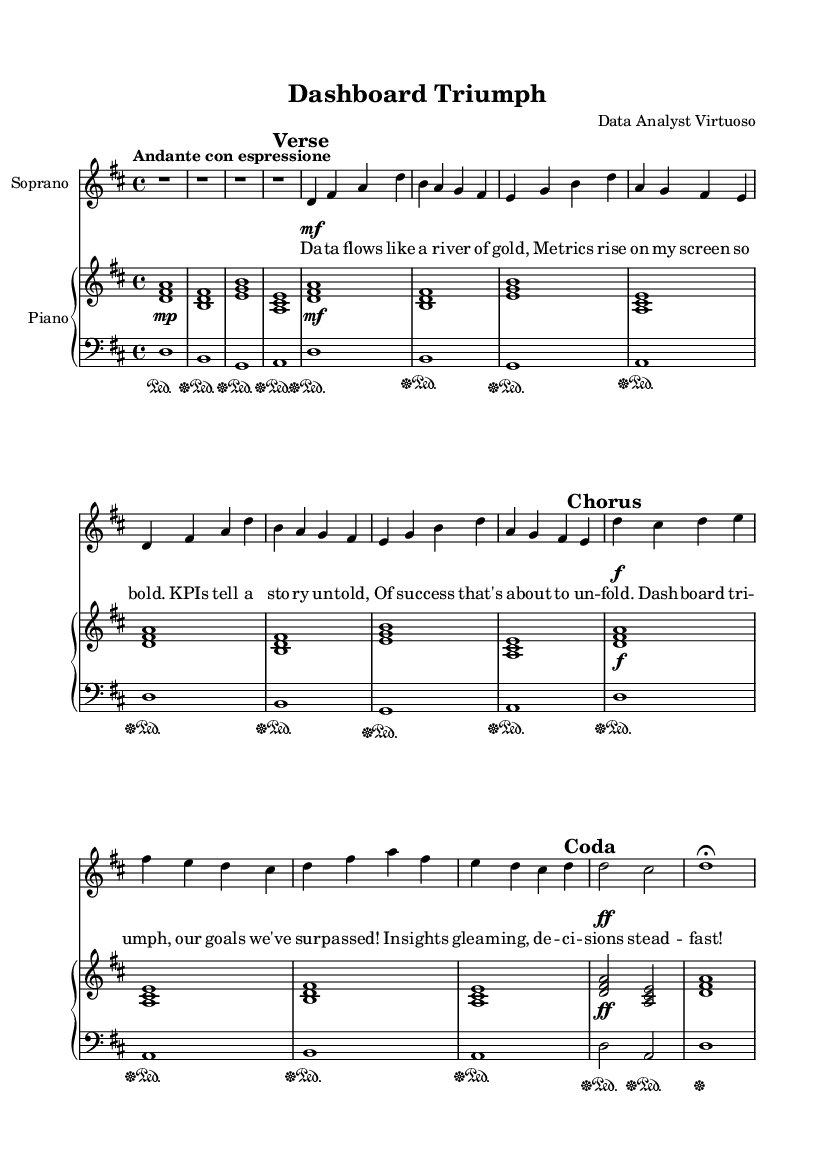What is the key signature of this music? The key signature is D major, which has two sharps: F# and C#.
Answer: D major What is the time signature of this music? The time signature is 4/4, indicating four beats per measure.
Answer: 4/4 What is the tempo marking for this piece? The tempo marking indicates "Andante con espressione," suggesting a moderate speed with expression.
Answer: Andante con espressione How many measures are in the verse section? By counting the number of segments in the verse, there are 8 measures.
Answer: 8 What dynamic level is indicated in the chorus? The chorus indicates a dynamic level of forte (f), which means to play loudly.
Answer: forte What is the primary theme celebrated in the lyrics? The lyrics celebrate achievements and milestones through metrics and success in a dashboard.
Answer: Achievements and milestones What overall emotion does the piece convey based on its characteristics? The piece conveys a sense of triumph and celebration, as captured in its joyful lyrics and lively dynamics.
Answer: Triumph and celebration 